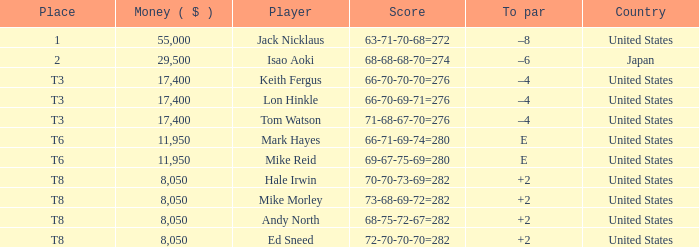What player has money larger than 11,950 and is placed in t8 and has the score of 73-68-69-72=282? None. 